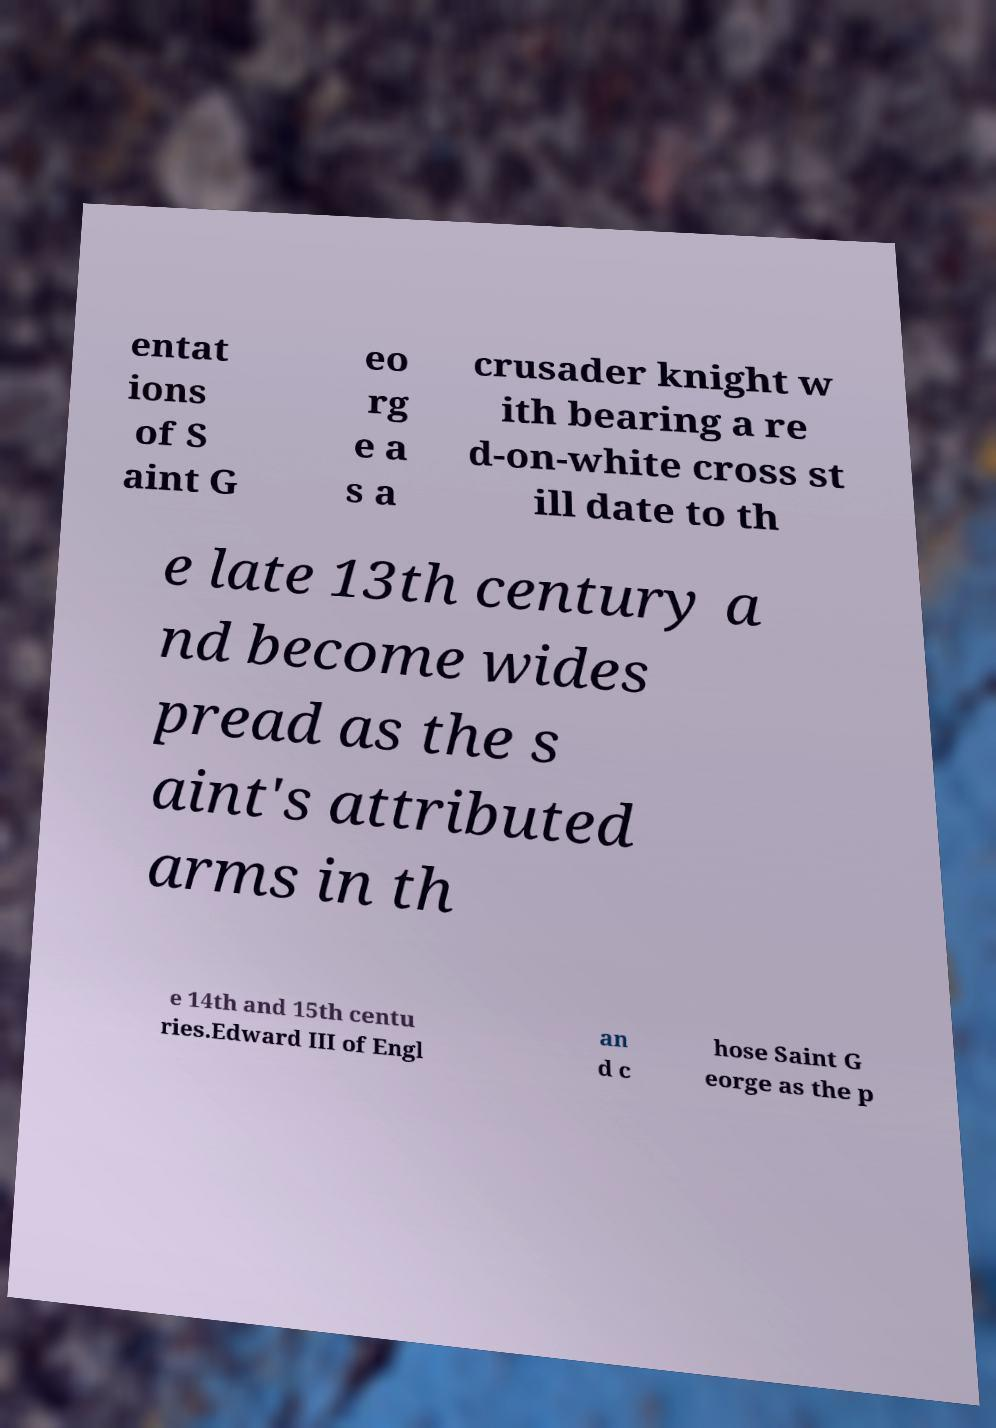For documentation purposes, I need the text within this image transcribed. Could you provide that? entat ions of S aint G eo rg e a s a crusader knight w ith bearing a re d-on-white cross st ill date to th e late 13th century a nd become wides pread as the s aint's attributed arms in th e 14th and 15th centu ries.Edward III of Engl an d c hose Saint G eorge as the p 